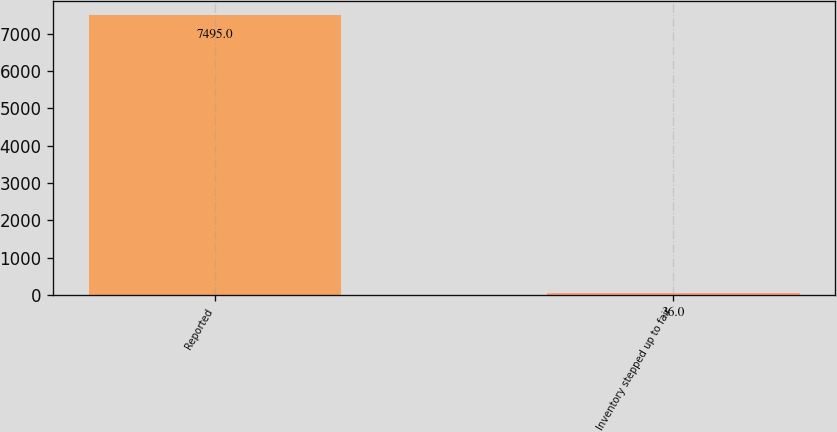Convert chart to OTSL. <chart><loc_0><loc_0><loc_500><loc_500><bar_chart><fcel>Reported<fcel>Inventory stepped up to fair<nl><fcel>7495<fcel>36<nl></chart> 